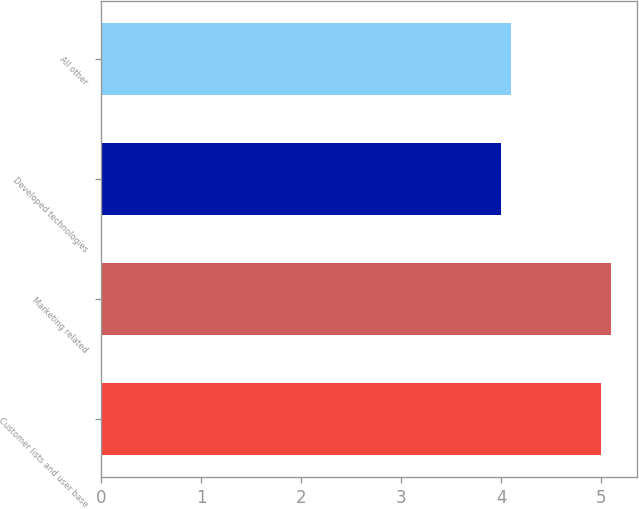<chart> <loc_0><loc_0><loc_500><loc_500><bar_chart><fcel>Customer lists and user base<fcel>Marketing related<fcel>Developed technologies<fcel>All other<nl><fcel>5<fcel>5.1<fcel>4<fcel>4.1<nl></chart> 